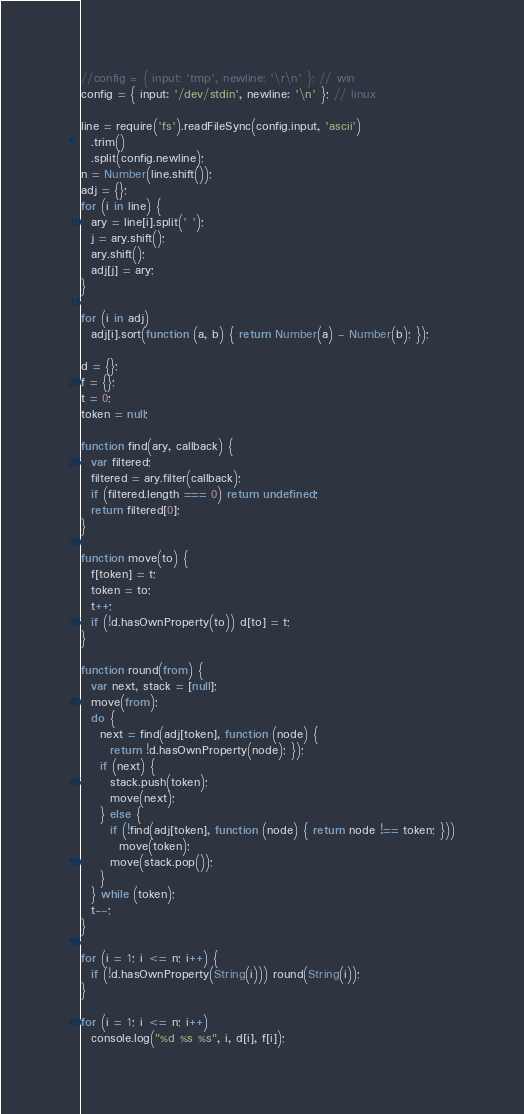Convert code to text. <code><loc_0><loc_0><loc_500><loc_500><_JavaScript_>//config = { input: 'tmp', newline: '\r\n' }; // win
config = { input: '/dev/stdin', newline: '\n' }; // linux

line = require('fs').readFileSync(config.input, 'ascii')
  .trim()
  .split(config.newline);
n = Number(line.shift());
adj = {};
for (i in line) {
  ary = line[i].split(' ');
  j = ary.shift();
  ary.shift();
  adj[j] = ary;
}

for (i in adj)
  adj[i].sort(function (a, b) { return Number(a) - Number(b); });

d = {};
f = {};
t = 0;
token = null;

function find(ary, callback) {
  var filtered;
  filtered = ary.filter(callback);
  if (filtered.length === 0) return undefined;
  return filtered[0];
}

function move(to) {
  f[token] = t;
  token = to;
  t++;
  if (!d.hasOwnProperty(to)) d[to] = t;
}

function round(from) {
  var next, stack = [null];
  move(from);
  do {
    next = find(adj[token], function (node) {
      return !d.hasOwnProperty(node); });
    if (next) {
      stack.push(token);
      move(next);
    } else {
      if (!find(adj[token], function (node) { return node !== token; }))
        move(token);
      move(stack.pop());
    }
  } while (token);
  t--;
}

for (i = 1; i <= n; i++) {
  if (!d.hasOwnProperty(String(i))) round(String(i));
}

for (i = 1; i <= n; i++)
  console.log("%d %s %s", i, d[i], f[i]);</code> 